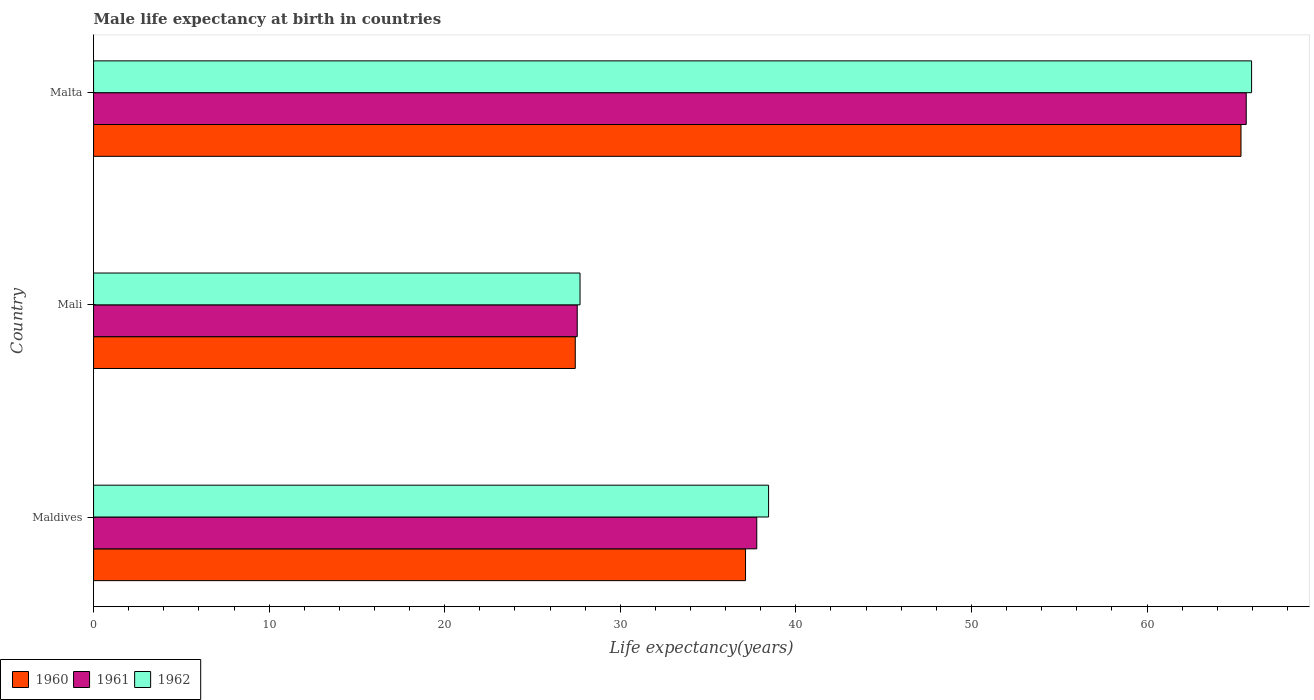Are the number of bars per tick equal to the number of legend labels?
Ensure brevity in your answer.  Yes. Are the number of bars on each tick of the Y-axis equal?
Your answer should be compact. Yes. How many bars are there on the 2nd tick from the bottom?
Keep it short and to the point. 3. What is the label of the 3rd group of bars from the top?
Your response must be concise. Maldives. In how many cases, is the number of bars for a given country not equal to the number of legend labels?
Your answer should be compact. 0. What is the male life expectancy at birth in 1962 in Maldives?
Make the answer very short. 38.45. Across all countries, what is the maximum male life expectancy at birth in 1960?
Offer a terse response. 65.35. Across all countries, what is the minimum male life expectancy at birth in 1961?
Offer a very short reply. 27.55. In which country was the male life expectancy at birth in 1961 maximum?
Provide a succinct answer. Malta. In which country was the male life expectancy at birth in 1962 minimum?
Provide a short and direct response. Mali. What is the total male life expectancy at birth in 1961 in the graph?
Offer a terse response. 130.97. What is the difference between the male life expectancy at birth in 1960 in Maldives and that in Malta?
Make the answer very short. -28.22. What is the difference between the male life expectancy at birth in 1962 in Malta and the male life expectancy at birth in 1960 in Mali?
Provide a short and direct response. 38.52. What is the average male life expectancy at birth in 1962 per country?
Make the answer very short. 44.04. What is the difference between the male life expectancy at birth in 1960 and male life expectancy at birth in 1962 in Mali?
Offer a very short reply. -0.27. In how many countries, is the male life expectancy at birth in 1960 greater than 38 years?
Your response must be concise. 1. What is the ratio of the male life expectancy at birth in 1961 in Maldives to that in Mali?
Your response must be concise. 1.37. Is the male life expectancy at birth in 1961 in Maldives less than that in Malta?
Keep it short and to the point. Yes. What is the difference between the highest and the second highest male life expectancy at birth in 1960?
Ensure brevity in your answer.  28.22. What is the difference between the highest and the lowest male life expectancy at birth in 1960?
Make the answer very short. 37.92. In how many countries, is the male life expectancy at birth in 1960 greater than the average male life expectancy at birth in 1960 taken over all countries?
Make the answer very short. 1. How many countries are there in the graph?
Make the answer very short. 3. Are the values on the major ticks of X-axis written in scientific E-notation?
Give a very brief answer. No. What is the title of the graph?
Give a very brief answer. Male life expectancy at birth in countries. Does "2000" appear as one of the legend labels in the graph?
Your answer should be very brief. No. What is the label or title of the X-axis?
Give a very brief answer. Life expectancy(years). What is the label or title of the Y-axis?
Offer a terse response. Country. What is the Life expectancy(years) of 1960 in Maldives?
Make the answer very short. 37.13. What is the Life expectancy(years) of 1961 in Maldives?
Make the answer very short. 37.77. What is the Life expectancy(years) in 1962 in Maldives?
Ensure brevity in your answer.  38.45. What is the Life expectancy(years) in 1960 in Mali?
Ensure brevity in your answer.  27.44. What is the Life expectancy(years) in 1961 in Mali?
Provide a succinct answer. 27.55. What is the Life expectancy(years) of 1962 in Mali?
Offer a terse response. 27.71. What is the Life expectancy(years) in 1960 in Malta?
Make the answer very short. 65.35. What is the Life expectancy(years) of 1961 in Malta?
Your answer should be very brief. 65.65. What is the Life expectancy(years) in 1962 in Malta?
Your answer should be compact. 65.96. Across all countries, what is the maximum Life expectancy(years) of 1960?
Make the answer very short. 65.35. Across all countries, what is the maximum Life expectancy(years) of 1961?
Provide a succinct answer. 65.65. Across all countries, what is the maximum Life expectancy(years) of 1962?
Provide a succinct answer. 65.96. Across all countries, what is the minimum Life expectancy(years) of 1960?
Offer a terse response. 27.44. Across all countries, what is the minimum Life expectancy(years) in 1961?
Give a very brief answer. 27.55. Across all countries, what is the minimum Life expectancy(years) in 1962?
Offer a very short reply. 27.71. What is the total Life expectancy(years) of 1960 in the graph?
Provide a succinct answer. 129.92. What is the total Life expectancy(years) in 1961 in the graph?
Give a very brief answer. 130.97. What is the total Life expectancy(years) in 1962 in the graph?
Keep it short and to the point. 132.11. What is the difference between the Life expectancy(years) in 1960 in Maldives and that in Mali?
Ensure brevity in your answer.  9.7. What is the difference between the Life expectancy(years) in 1961 in Maldives and that in Mali?
Your answer should be compact. 10.22. What is the difference between the Life expectancy(years) in 1962 in Maldives and that in Mali?
Provide a short and direct response. 10.74. What is the difference between the Life expectancy(years) in 1960 in Maldives and that in Malta?
Offer a very short reply. -28.22. What is the difference between the Life expectancy(years) of 1961 in Maldives and that in Malta?
Provide a short and direct response. -27.88. What is the difference between the Life expectancy(years) of 1962 in Maldives and that in Malta?
Your answer should be compact. -27.51. What is the difference between the Life expectancy(years) of 1960 in Mali and that in Malta?
Provide a short and direct response. -37.92. What is the difference between the Life expectancy(years) of 1961 in Mali and that in Malta?
Provide a short and direct response. -38.1. What is the difference between the Life expectancy(years) of 1962 in Mali and that in Malta?
Give a very brief answer. -38.25. What is the difference between the Life expectancy(years) in 1960 in Maldives and the Life expectancy(years) in 1961 in Mali?
Provide a short and direct response. 9.59. What is the difference between the Life expectancy(years) of 1960 in Maldives and the Life expectancy(years) of 1962 in Mali?
Your response must be concise. 9.43. What is the difference between the Life expectancy(years) in 1961 in Maldives and the Life expectancy(years) in 1962 in Mali?
Your response must be concise. 10.07. What is the difference between the Life expectancy(years) of 1960 in Maldives and the Life expectancy(years) of 1961 in Malta?
Keep it short and to the point. -28.52. What is the difference between the Life expectancy(years) of 1960 in Maldives and the Life expectancy(years) of 1962 in Malta?
Your answer should be very brief. -28.82. What is the difference between the Life expectancy(years) of 1961 in Maldives and the Life expectancy(years) of 1962 in Malta?
Provide a succinct answer. -28.18. What is the difference between the Life expectancy(years) of 1960 in Mali and the Life expectancy(years) of 1961 in Malta?
Give a very brief answer. -38.22. What is the difference between the Life expectancy(years) of 1960 in Mali and the Life expectancy(years) of 1962 in Malta?
Give a very brief answer. -38.52. What is the difference between the Life expectancy(years) in 1961 in Mali and the Life expectancy(years) in 1962 in Malta?
Offer a very short reply. -38.41. What is the average Life expectancy(years) of 1960 per country?
Your answer should be compact. 43.31. What is the average Life expectancy(years) of 1961 per country?
Ensure brevity in your answer.  43.66. What is the average Life expectancy(years) in 1962 per country?
Your answer should be compact. 44.04. What is the difference between the Life expectancy(years) of 1960 and Life expectancy(years) of 1961 in Maldives?
Give a very brief answer. -0.64. What is the difference between the Life expectancy(years) of 1960 and Life expectancy(years) of 1962 in Maldives?
Offer a very short reply. -1.31. What is the difference between the Life expectancy(years) of 1961 and Life expectancy(years) of 1962 in Maldives?
Make the answer very short. -0.67. What is the difference between the Life expectancy(years) of 1960 and Life expectancy(years) of 1961 in Mali?
Give a very brief answer. -0.11. What is the difference between the Life expectancy(years) in 1960 and Life expectancy(years) in 1962 in Mali?
Give a very brief answer. -0.27. What is the difference between the Life expectancy(years) in 1961 and Life expectancy(years) in 1962 in Mali?
Offer a very short reply. -0.16. What is the difference between the Life expectancy(years) of 1960 and Life expectancy(years) of 1961 in Malta?
Make the answer very short. -0.3. What is the difference between the Life expectancy(years) of 1960 and Life expectancy(years) of 1962 in Malta?
Your answer should be very brief. -0.6. What is the difference between the Life expectancy(years) in 1961 and Life expectancy(years) in 1962 in Malta?
Ensure brevity in your answer.  -0.3. What is the ratio of the Life expectancy(years) of 1960 in Maldives to that in Mali?
Offer a terse response. 1.35. What is the ratio of the Life expectancy(years) in 1961 in Maldives to that in Mali?
Offer a terse response. 1.37. What is the ratio of the Life expectancy(years) of 1962 in Maldives to that in Mali?
Provide a short and direct response. 1.39. What is the ratio of the Life expectancy(years) in 1960 in Maldives to that in Malta?
Offer a terse response. 0.57. What is the ratio of the Life expectancy(years) in 1961 in Maldives to that in Malta?
Offer a terse response. 0.58. What is the ratio of the Life expectancy(years) in 1962 in Maldives to that in Malta?
Offer a terse response. 0.58. What is the ratio of the Life expectancy(years) of 1960 in Mali to that in Malta?
Provide a succinct answer. 0.42. What is the ratio of the Life expectancy(years) in 1961 in Mali to that in Malta?
Offer a very short reply. 0.42. What is the ratio of the Life expectancy(years) in 1962 in Mali to that in Malta?
Your answer should be compact. 0.42. What is the difference between the highest and the second highest Life expectancy(years) in 1960?
Your response must be concise. 28.22. What is the difference between the highest and the second highest Life expectancy(years) of 1961?
Your response must be concise. 27.88. What is the difference between the highest and the second highest Life expectancy(years) of 1962?
Make the answer very short. 27.51. What is the difference between the highest and the lowest Life expectancy(years) of 1960?
Give a very brief answer. 37.92. What is the difference between the highest and the lowest Life expectancy(years) of 1961?
Keep it short and to the point. 38.1. What is the difference between the highest and the lowest Life expectancy(years) of 1962?
Your answer should be compact. 38.25. 